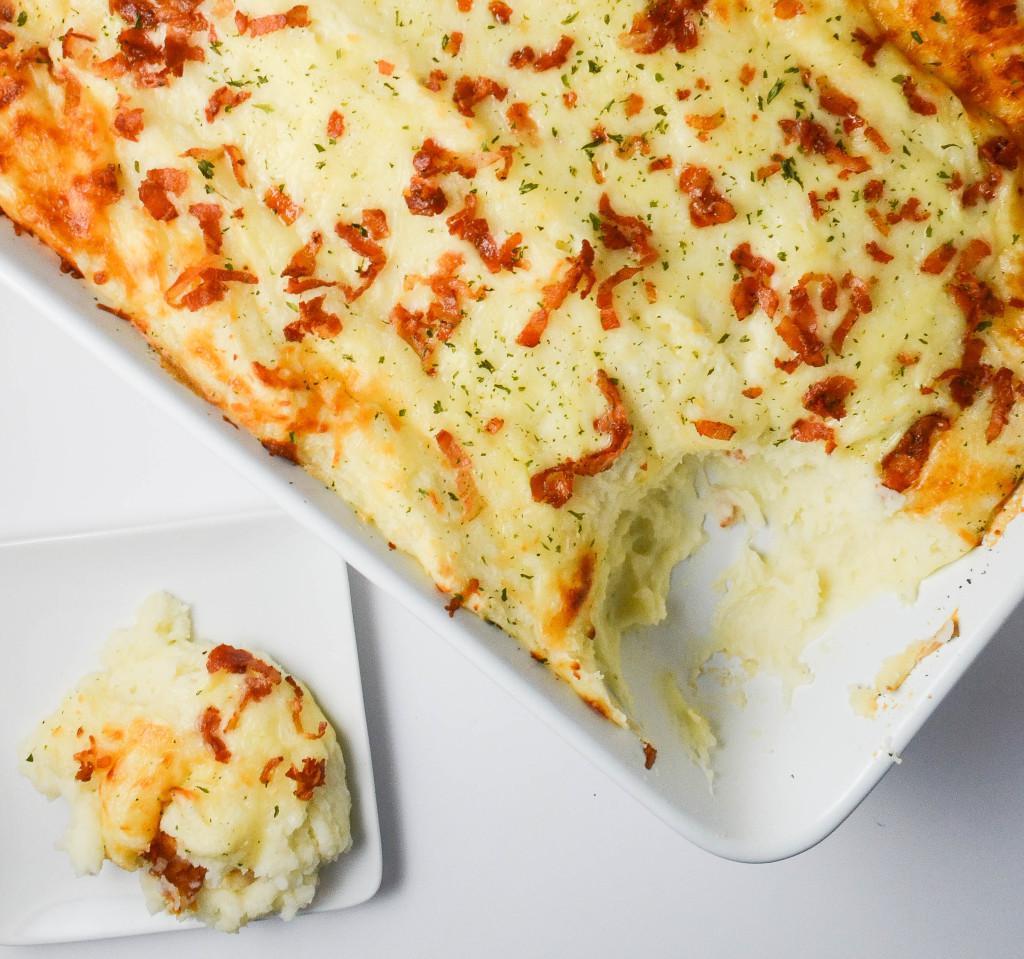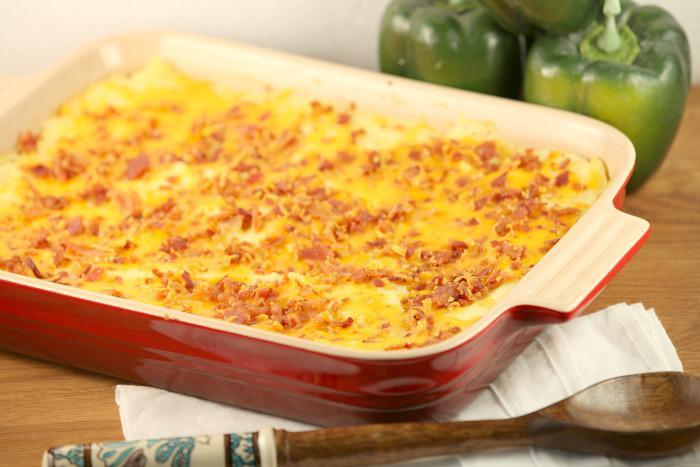The first image is the image on the left, the second image is the image on the right. For the images displayed, is the sentence "The food in one of the images is sitting in a red casserole dish." factually correct? Answer yes or no. Yes. The first image is the image on the left, the second image is the image on the right. Assess this claim about the two images: "One image shows a cheese topped casserole in a reddish-orange dish with white interior, and the other image shows a casserole in a solid white dish.". Correct or not? Answer yes or no. Yes. 